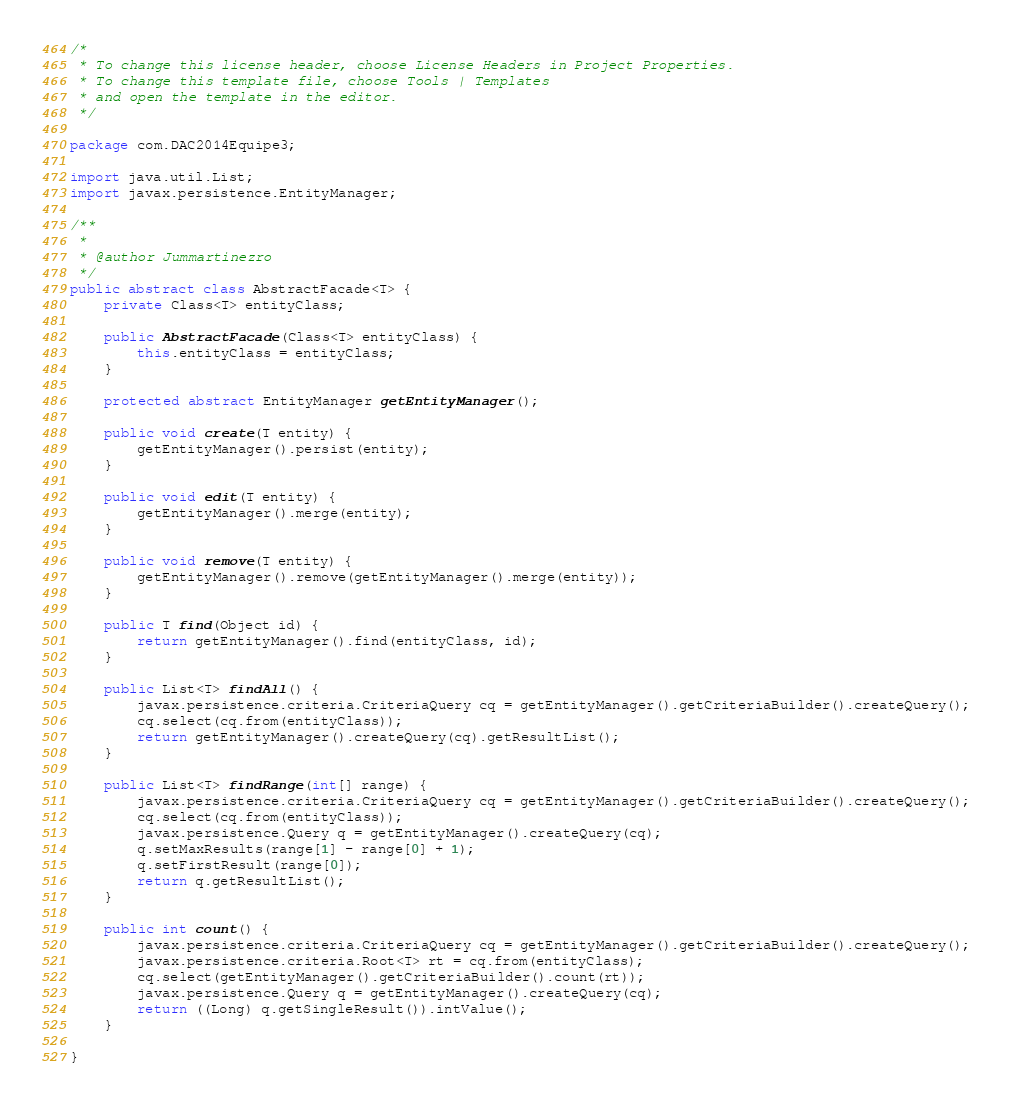Convert code to text. <code><loc_0><loc_0><loc_500><loc_500><_Java_>/*
 * To change this license header, choose License Headers in Project Properties.
 * To change this template file, choose Tools | Templates
 * and open the template in the editor.
 */

package com.DAC2014Equipe3;

import java.util.List;
import javax.persistence.EntityManager;

/**
 *
 * @author Jummartinezro
 */
public abstract class AbstractFacade<T> {
    private Class<T> entityClass;

    public AbstractFacade(Class<T> entityClass) {
        this.entityClass = entityClass;
    }

    protected abstract EntityManager getEntityManager();

    public void create(T entity) {
        getEntityManager().persist(entity);
    }

    public void edit(T entity) {
        getEntityManager().merge(entity);
    }

    public void remove(T entity) {
        getEntityManager().remove(getEntityManager().merge(entity));
    }

    public T find(Object id) {
        return getEntityManager().find(entityClass, id);
    }

    public List<T> findAll() {
        javax.persistence.criteria.CriteriaQuery cq = getEntityManager().getCriteriaBuilder().createQuery();
        cq.select(cq.from(entityClass));
        return getEntityManager().createQuery(cq).getResultList();
    }

    public List<T> findRange(int[] range) {
        javax.persistence.criteria.CriteriaQuery cq = getEntityManager().getCriteriaBuilder().createQuery();
        cq.select(cq.from(entityClass));
        javax.persistence.Query q = getEntityManager().createQuery(cq);
        q.setMaxResults(range[1] - range[0] + 1);
        q.setFirstResult(range[0]);
        return q.getResultList();
    }

    public int count() {
        javax.persistence.criteria.CriteriaQuery cq = getEntityManager().getCriteriaBuilder().createQuery();
        javax.persistence.criteria.Root<T> rt = cq.from(entityClass);
        cq.select(getEntityManager().getCriteriaBuilder().count(rt));
        javax.persistence.Query q = getEntityManager().createQuery(cq);
        return ((Long) q.getSingleResult()).intValue();
    }

}
</code> 